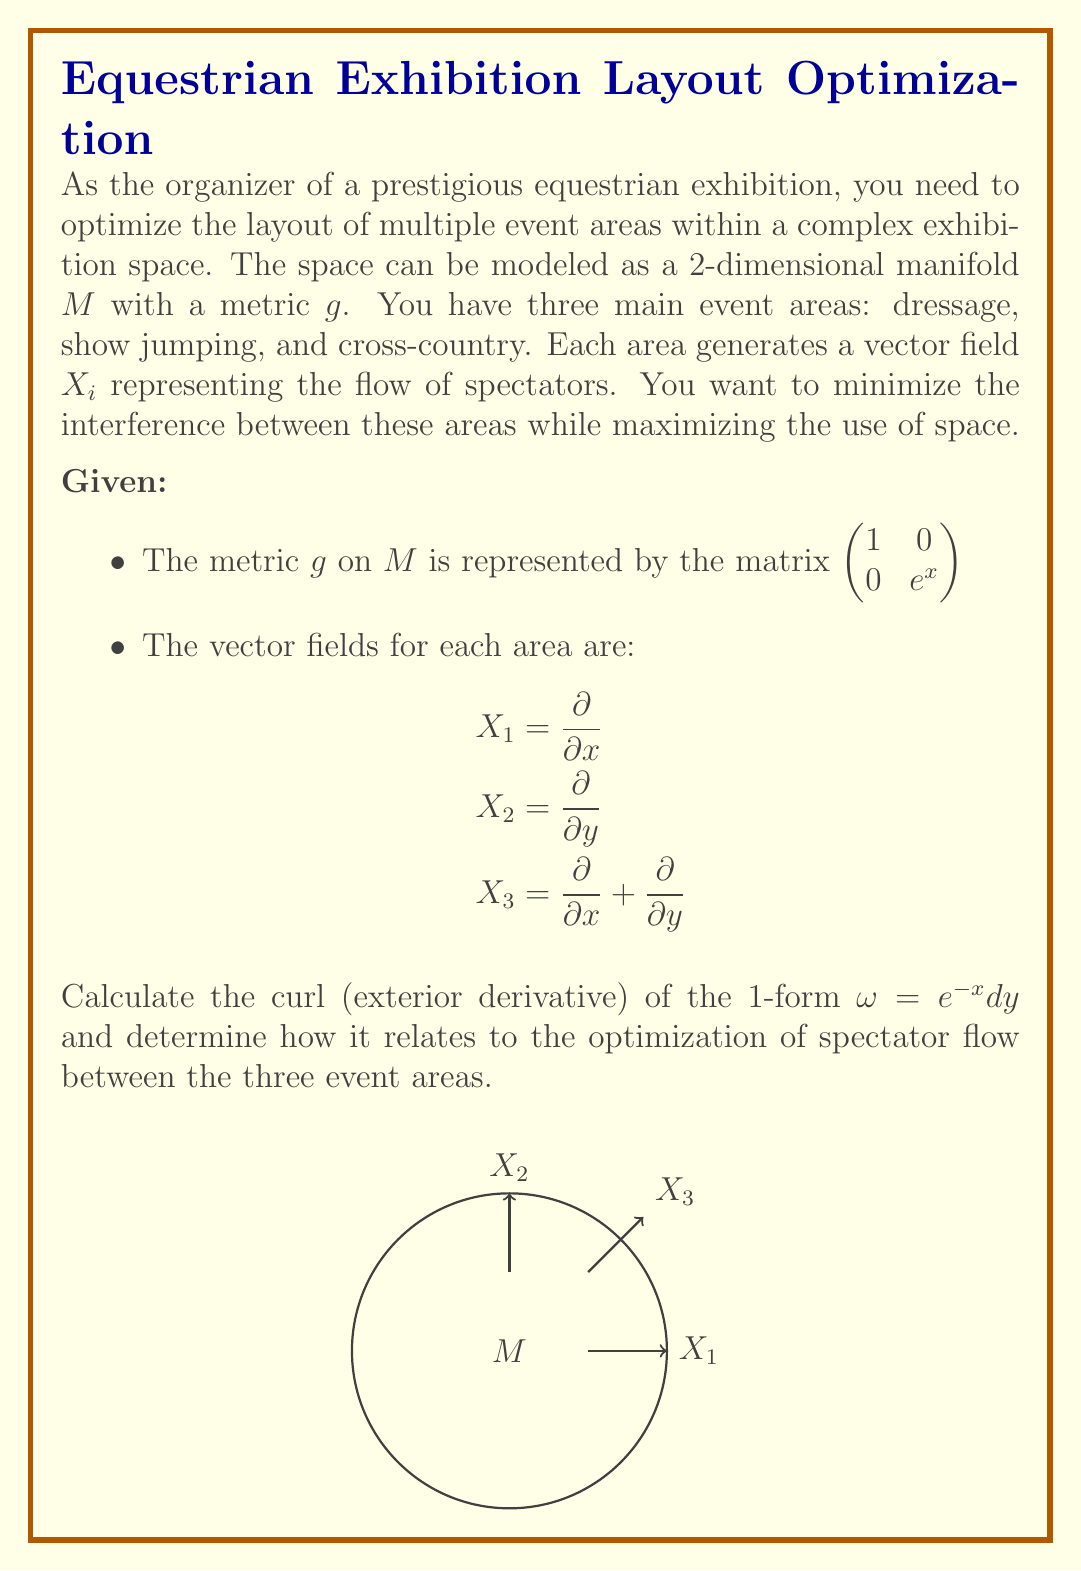Can you answer this question? Let's approach this step-by-step:

1) First, we need to calculate the curl of the 1-form $\omega = e^{-x}dy$. The curl is given by the exterior derivative $d\omega$.

2) For a 1-form $\omega = f(x,y)dx + g(x,y)dy$, the exterior derivative is:
   $d\omega = (\frac{\partial g}{\partial x} - \frac{\partial f}{\partial y})dx \wedge dy$

3) In our case, $f(x,y) = 0$ and $g(x,y) = e^{-x}$. So:
   $d\omega = (\frac{\partial e^{-x}}{\partial x} - 0)dx \wedge dy = -e^{-x}dx \wedge dy$

4) Now, let's consider how this relates to our vector fields:
   - $X_1 = \frac{\partial}{\partial x}$ (dressage area)
   - $X_2 = \frac{\partial}{\partial y}$ (show jumping area)
   - $X_3 = \frac{\partial}{\partial x} + \frac{\partial}{\partial y}$ (cross-country area)

5) The curl $d\omega$ measures the rotation of the vector field. In our case, it's non-zero, indicating a rotational component in the spectator flow.

6) To optimize the layout, we want to minimize interference between areas. This means minimizing the work done against the curl.

7) The work done by a vector field $X$ against the curl is given by the interior product $i_X(d\omega)$:
   
   For $X_1$: $i_{X_1}(d\omega) = -e^{-x}dy$
   For $X_2$: $i_{X_2}(d\omega) = e^{-x}dx$
   For $X_3$: $i_{X_3}(d\omega) = 0$

8) The cross-country area ($X_3$) has zero work against the curl, making it the most efficient in terms of spectator flow.

9) The dressage ($X_1$) and show jumping ($X_2$) areas have non-zero work against the curl, indicating potential interference.

10) To optimize the layout, we should:
    - Place the cross-country area ($X_3$) where the spectator flow is highest
    - Arrange the dressage ($X_1$) and show jumping ($X_2$) areas to minimize their interference, possibly by placing them at opposite ends of the exhibition space.
Answer: Place cross-country centrally; dressage and show jumping at opposite ends. 